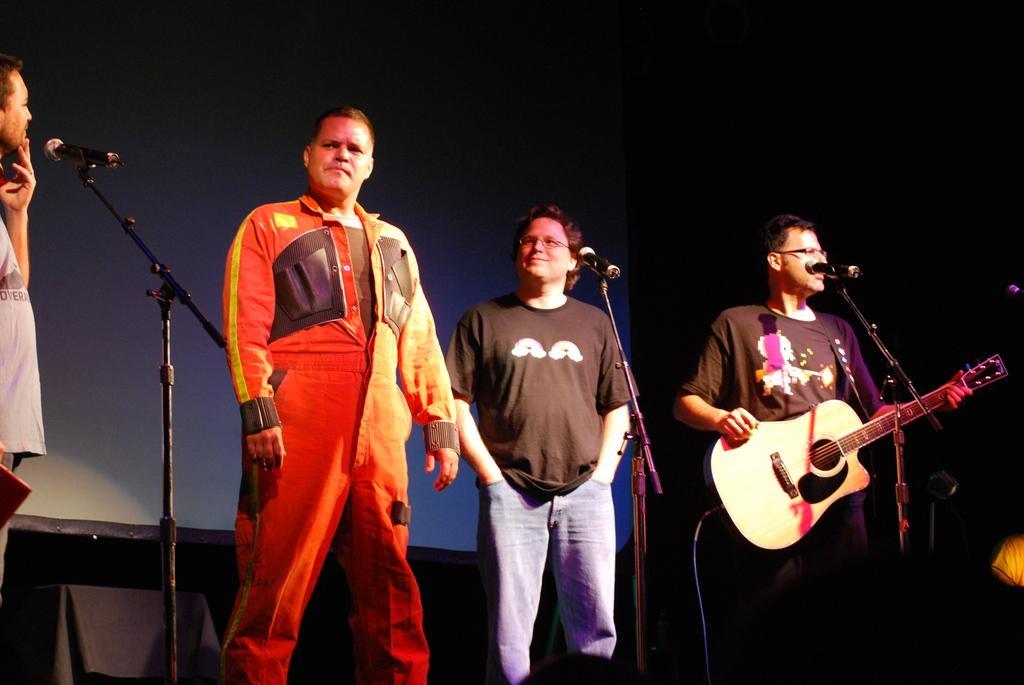Can you describe this image briefly? In this image I can see four men are standing in front of the mike stands. The person who is standing on the right side is holding a guitar in his hands. In the background I can see a black color curtain. 